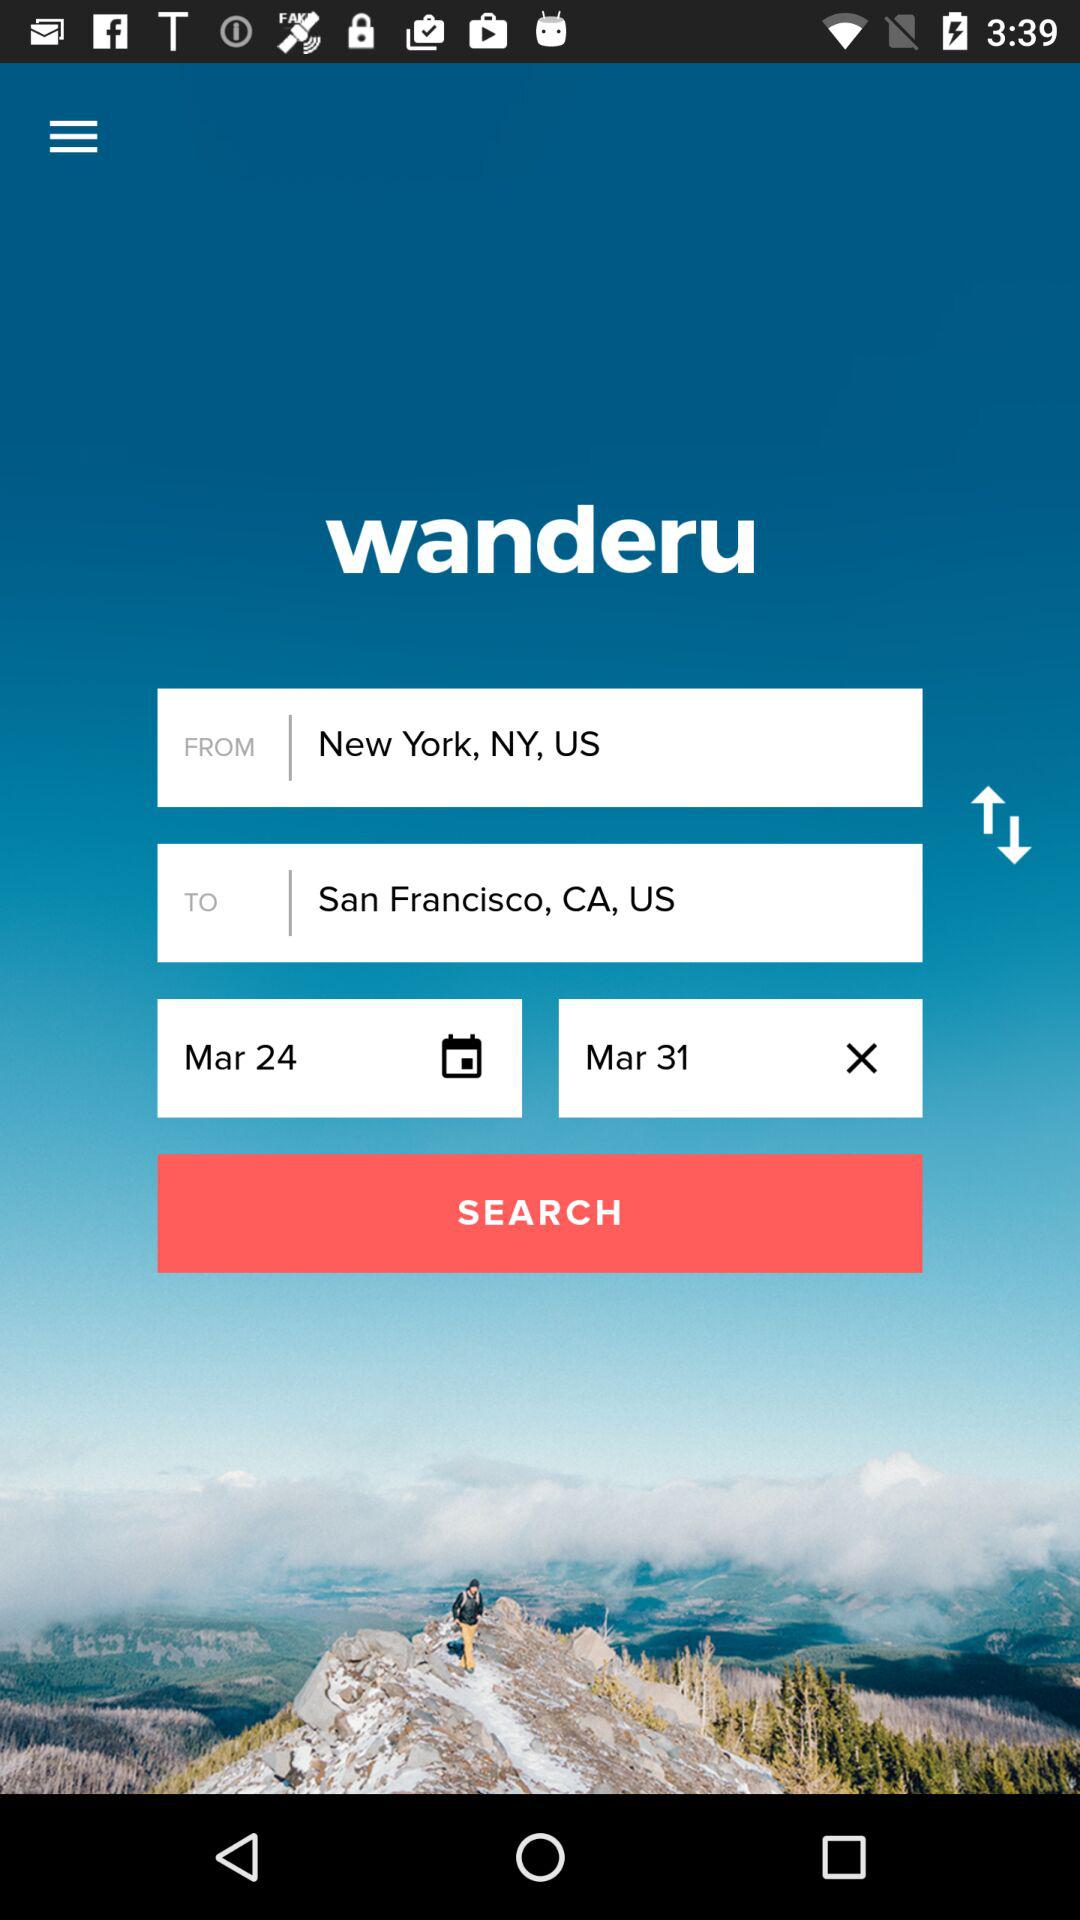Which location is selected for "FROM"? The selected location is New York, NY, US. 